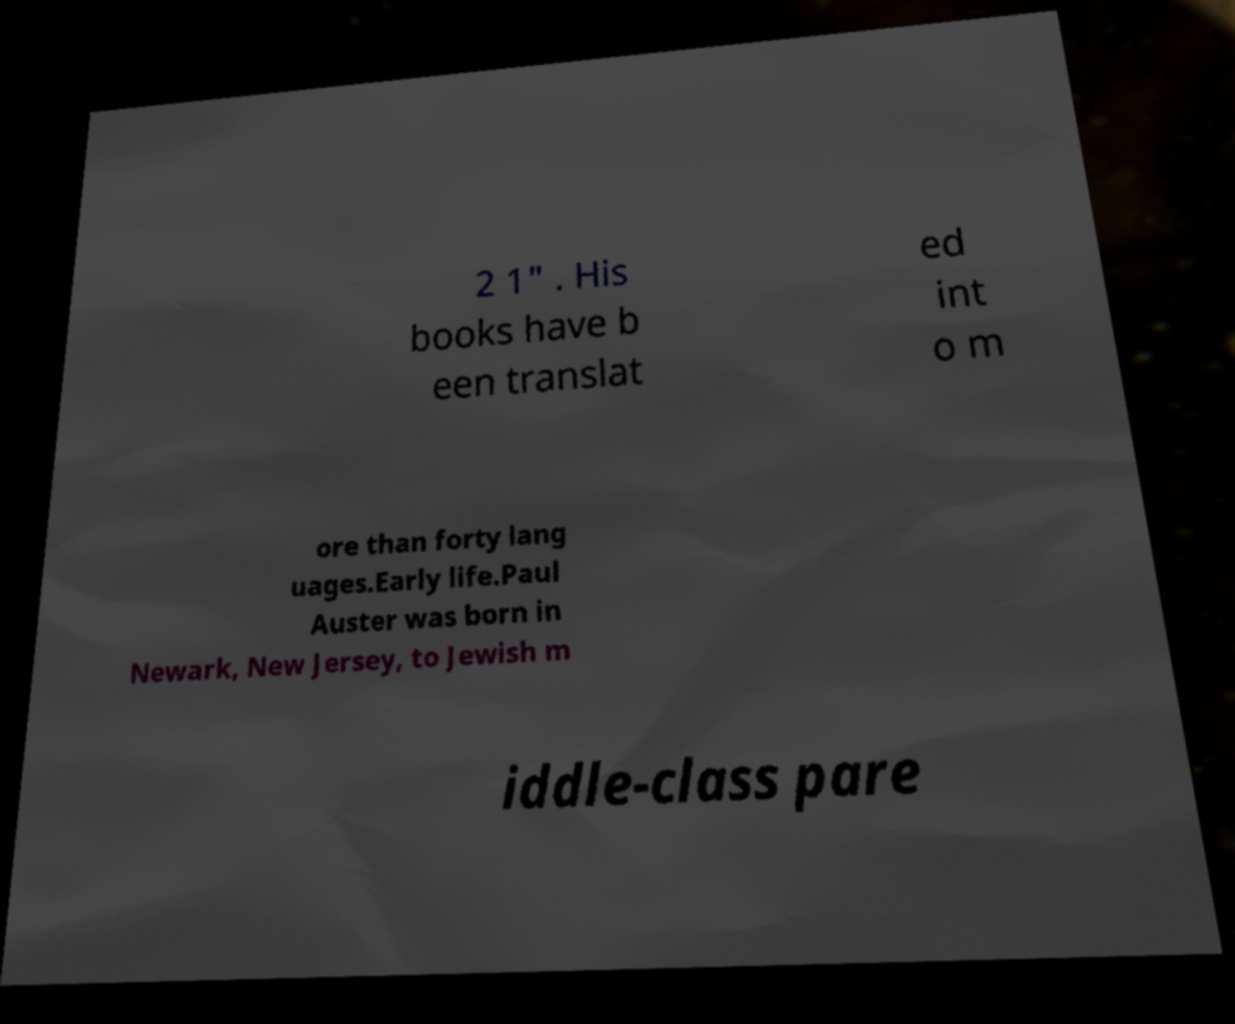Can you accurately transcribe the text from the provided image for me? 2 1" . His books have b een translat ed int o m ore than forty lang uages.Early life.Paul Auster was born in Newark, New Jersey, to Jewish m iddle-class pare 